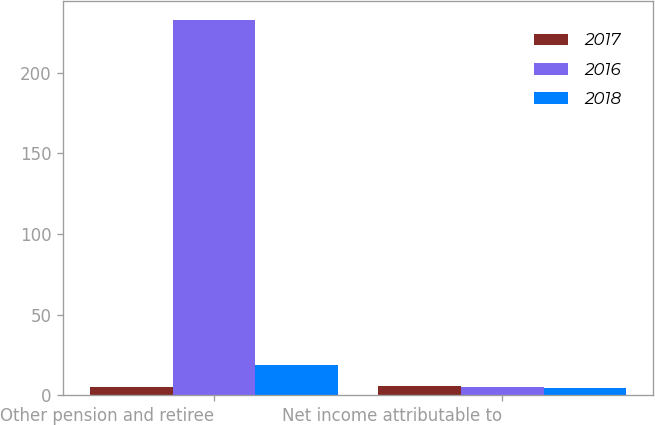Convert chart to OTSL. <chart><loc_0><loc_0><loc_500><loc_500><stacked_bar_chart><ecel><fcel>Other pension and retiree<fcel>Net income attributable to<nl><fcel>2017<fcel>5.445<fcel>5.66<nl><fcel>2016<fcel>233<fcel>5.23<nl><fcel>2018<fcel>19<fcel>4.85<nl></chart> 